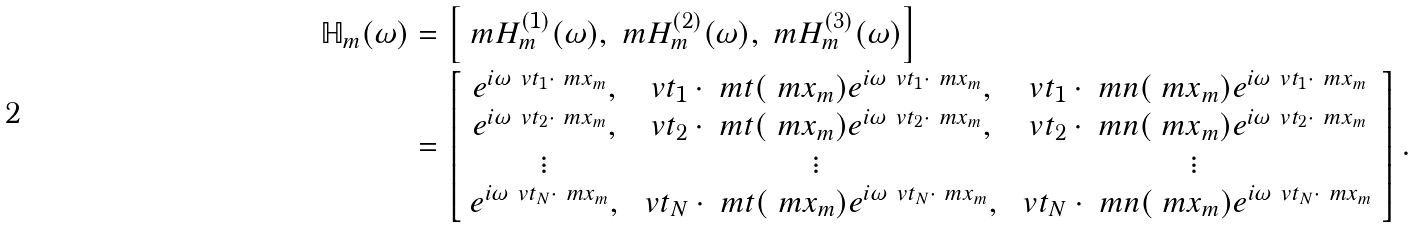Convert formula to latex. <formula><loc_0><loc_0><loc_500><loc_500>\mathbb { H } _ { m } ( \omega ) & = \left [ \ m H _ { m } ^ { ( 1 ) } ( \omega ) , \ m H _ { m } ^ { ( 2 ) } ( \omega ) , \ m H _ { m } ^ { ( 3 ) } ( \omega ) \right ] \\ & = \left [ \begin{array} { c c c } e ^ { i \omega \ v t _ { 1 } \cdot \ m x _ { m } } , & \ v t _ { 1 } \cdot \ m t ( \ m x _ { m } ) e ^ { i \omega \ v t _ { 1 } \cdot \ m x _ { m } } , & \ v t _ { 1 } \cdot \ m n ( \ m x _ { m } ) e ^ { i \omega \ v t _ { 1 } \cdot \ m x _ { m } } \\ e ^ { i \omega \ v t _ { 2 } \cdot \ m x _ { m } } , & \ v t _ { 2 } \cdot \ m t ( \ m x _ { m } ) e ^ { i \omega \ v t _ { 2 } \cdot \ m x _ { m } } , & \ v t _ { 2 } \cdot \ m n ( \ m x _ { m } ) e ^ { i \omega \ v t _ { 2 } \cdot \ m x _ { m } } \\ \vdots & \vdots & \vdots \\ e ^ { i \omega \ v t _ { N } \cdot \ m x _ { m } } , & \ v t _ { N } \cdot \ m t ( \ m x _ { m } ) e ^ { i \omega \ v t _ { N } \cdot \ m x _ { m } } , & \ v t _ { N } \cdot \ m n ( \ m x _ { m } ) e ^ { i \omega \ v t _ { N } \cdot \ m x _ { m } } \\ \end{array} \right ] .</formula> 